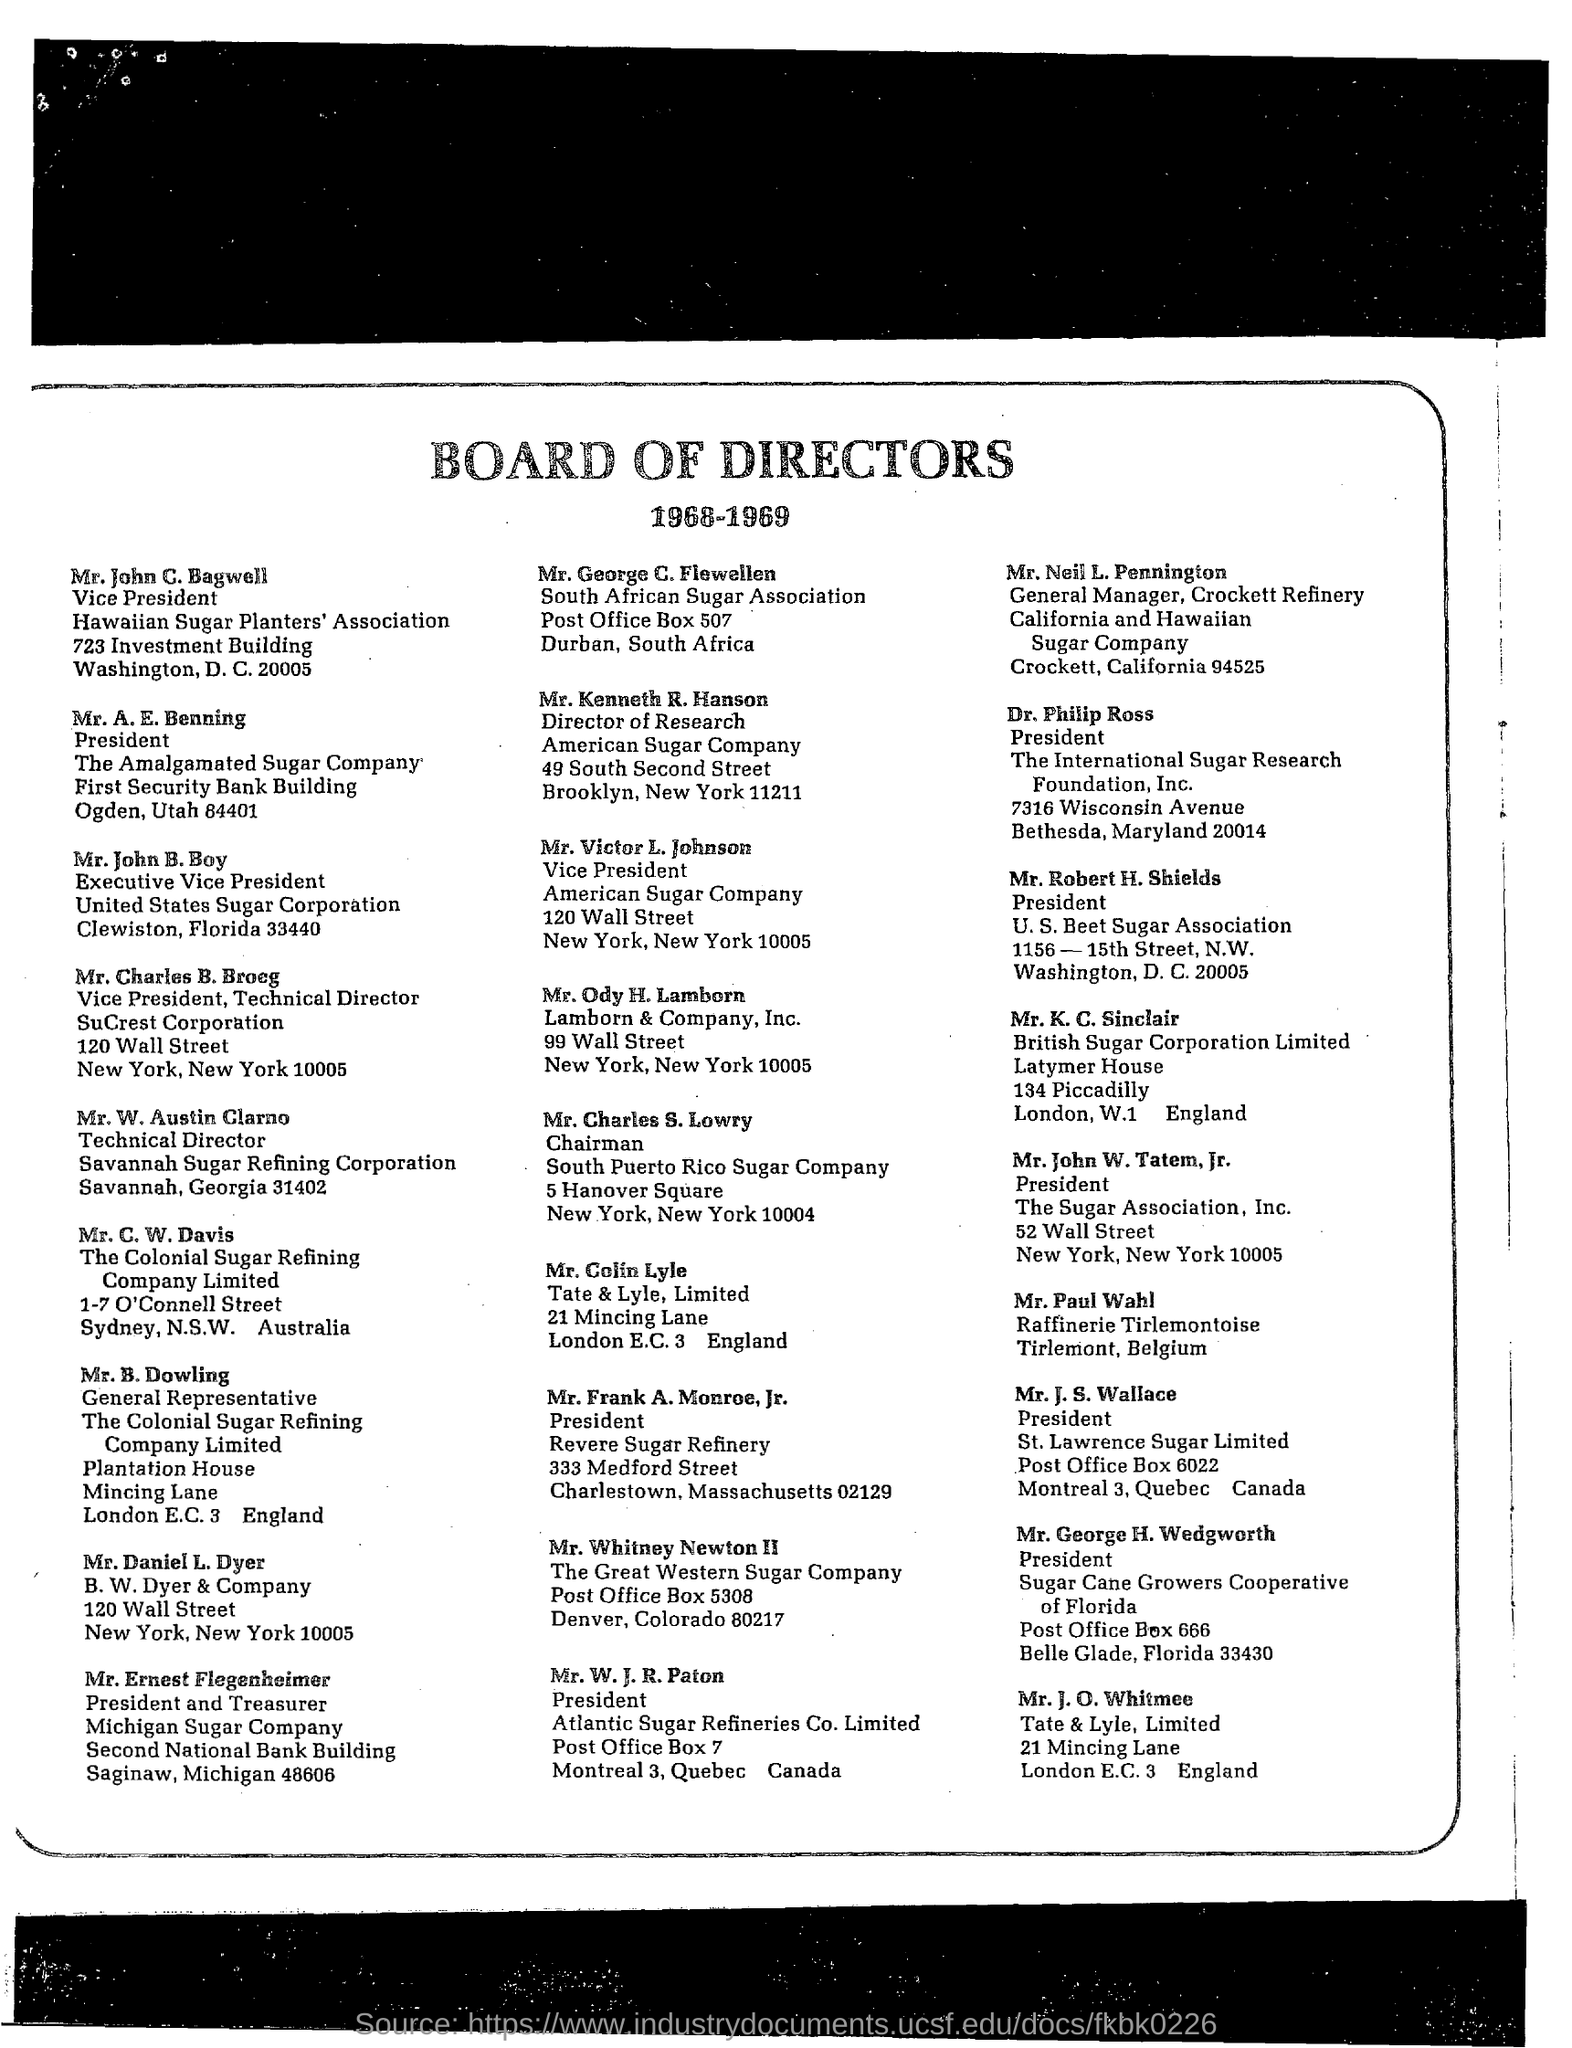Give some essential details in this illustration. Mr. Whitney Newton II was the Director of The Great Western Sugar Company. 